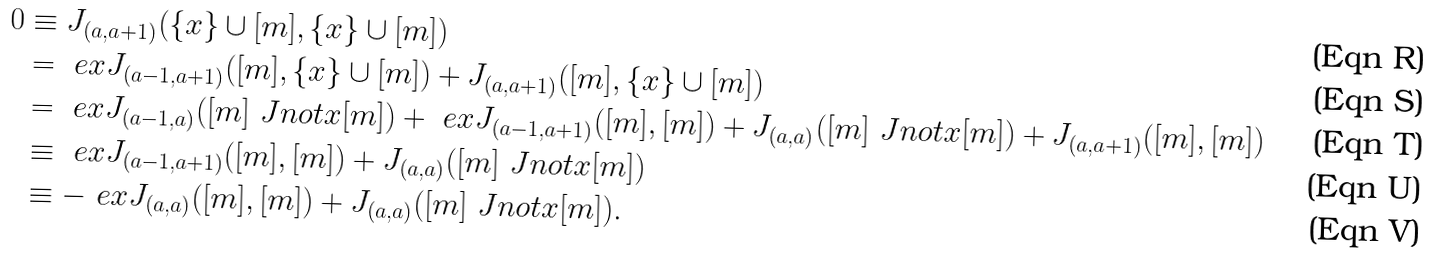<formula> <loc_0><loc_0><loc_500><loc_500>0 & \equiv J _ { ( a , a + 1 ) } ( \{ x \} \cup [ m ] , \{ x \} \cup [ m ] ) \\ & = \ e { x } J _ { ( a - 1 , a + 1 ) } ( [ m ] , \{ x \} \cup [ m ] ) + J _ { ( a , a + 1 ) } ( [ m ] , \{ x \} \cup [ m ] ) \\ & = \ e { x } J _ { ( a - 1 , a ) } ( [ m ] \ J n o t { x } [ m ] ) + \ e { x } J _ { ( a - 1 , a + 1 ) } ( [ m ] , [ m ] ) + J _ { ( a , a ) } ( [ m ] \ J n o t { x } [ m ] ) + J _ { ( a , a + 1 ) } ( [ m ] , [ m ] ) \\ & \equiv \ e { x } J _ { ( a - 1 , a + 1 ) } ( [ m ] , [ m ] ) + J _ { ( a , a ) } ( [ m ] \ J n o t { x } [ m ] ) \\ & \equiv - \ e { x } J _ { ( a , a ) } ( [ m ] , [ m ] ) + J _ { ( a , a ) } ( [ m ] \ J n o t { x } [ m ] ) .</formula> 